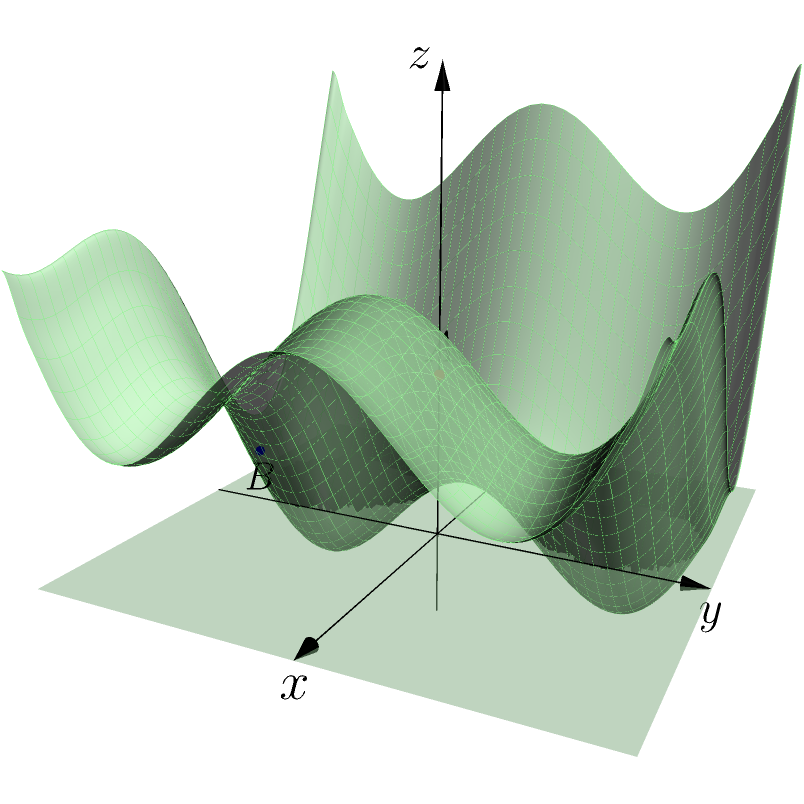Given the cost function $f(x,y) = 0.5(x^2+y^2)+\sin(2x)+\cos(2y)$ visualized as a 3D surface plot above, identify the point that represents the global minimum. Is it point A (red) or point B (blue)? Justify your answer using concepts from optimization in machine learning. To determine the global minimum of the cost function, we need to analyze the characteristics of points A and B:

1. Gradient at minimum: At the global minimum, the gradient of the function should be zero in all directions.

2. Visual inspection: The surface plot shows that point B (blue) is lower on the z-axis than point A (red).

3. Function analysis:
   - Point A is at (0, 0, 1.5)
   - Point B is at (0, -π/2, 0.5)

4. Calculating partial derivatives:
   $$\frac{\partial f}{\partial x} = x + 2\cos(2x)$$
   $$\frac{\partial f}{\partial y} = y - 2\sin(2y)$$

5. Evaluating at point B (0, -π/2):
   $$\frac{\partial f}{\partial x}|_{(0,-\pi/2)} = 0 + 2\cos(0) = 2$$
   $$\frac{\partial f}{\partial y}|_{(0,-\pi/2)} = -\pi/2 - 2\sin(-\pi) = -\pi/2$$

6. Since the gradient is not zero at point B, it is not the global minimum.

7. Point A (0, 0, 1.5) is actually a local maximum, not the global minimum.

8. The global minimum is neither A nor B, but occurs at four symmetric points: approximately (±1.16, ±1.16, -0.59).

In machine learning, finding the global minimum of the cost function is crucial for optimizing model parameters. This example illustrates the importance of thorough analysis and the potential pitfalls of relying solely on visual inspection or local extrema.
Answer: Neither A nor B; global minimum at (±1.16, ±1.16, -0.59) 